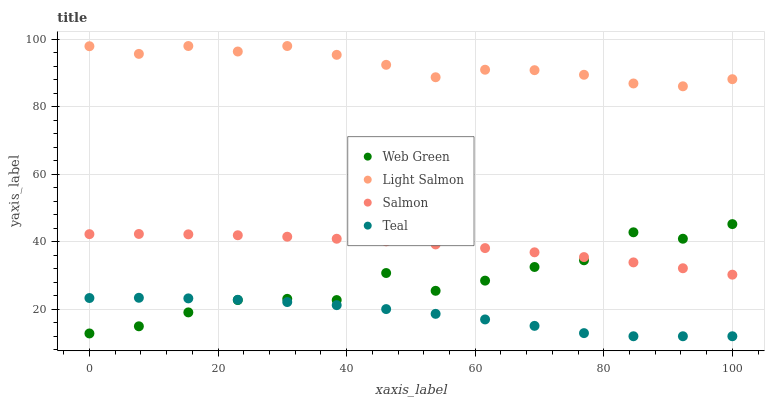Does Teal have the minimum area under the curve?
Answer yes or no. Yes. Does Light Salmon have the maximum area under the curve?
Answer yes or no. Yes. Does Salmon have the minimum area under the curve?
Answer yes or no. No. Does Salmon have the maximum area under the curve?
Answer yes or no. No. Is Salmon the smoothest?
Answer yes or no. Yes. Is Web Green the roughest?
Answer yes or no. Yes. Is Teal the smoothest?
Answer yes or no. No. Is Teal the roughest?
Answer yes or no. No. Does Teal have the lowest value?
Answer yes or no. Yes. Does Salmon have the lowest value?
Answer yes or no. No. Does Light Salmon have the highest value?
Answer yes or no. Yes. Does Salmon have the highest value?
Answer yes or no. No. Is Teal less than Light Salmon?
Answer yes or no. Yes. Is Salmon greater than Teal?
Answer yes or no. Yes. Does Teal intersect Web Green?
Answer yes or no. Yes. Is Teal less than Web Green?
Answer yes or no. No. Is Teal greater than Web Green?
Answer yes or no. No. Does Teal intersect Light Salmon?
Answer yes or no. No. 